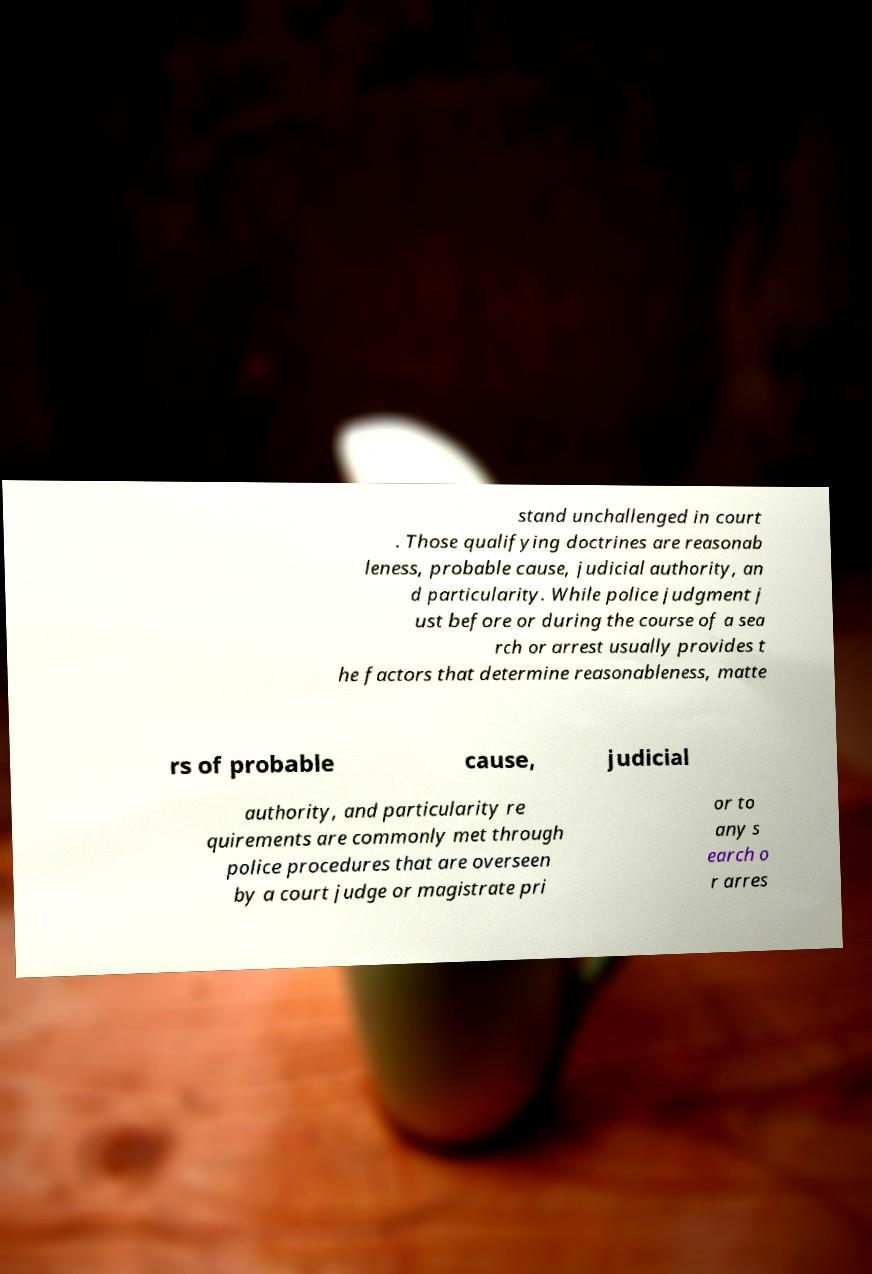Can you read and provide the text displayed in the image?This photo seems to have some interesting text. Can you extract and type it out for me? stand unchallenged in court . Those qualifying doctrines are reasonab leness, probable cause, judicial authority, an d particularity. While police judgment j ust before or during the course of a sea rch or arrest usually provides t he factors that determine reasonableness, matte rs of probable cause, judicial authority, and particularity re quirements are commonly met through police procedures that are overseen by a court judge or magistrate pri or to any s earch o r arres 